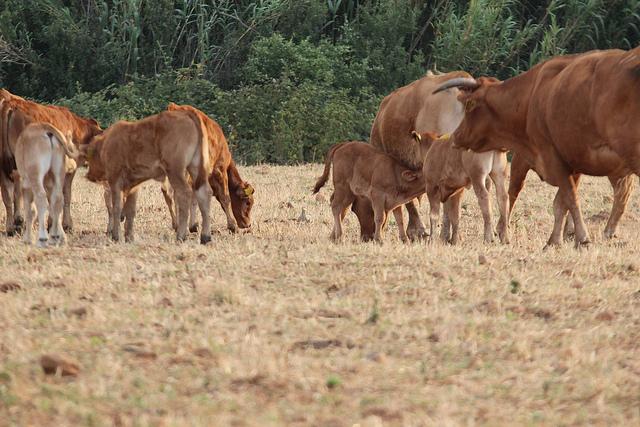What color is the grass?
Be succinct. Brown. Is this out in the wild?
Short answer required. Yes. Why aren't all the cows the same size?
Concise answer only. Some are babies. 